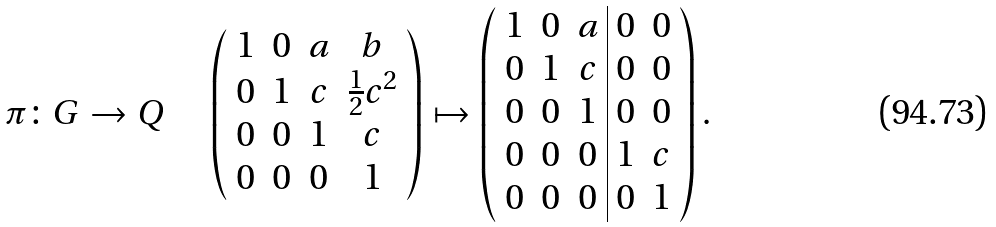Convert formula to latex. <formula><loc_0><loc_0><loc_500><loc_500>\pi \colon G \rightarrow Q \quad \left ( \begin{array} { c c c c } 1 & 0 & a & b \\ 0 & 1 & c & \frac { 1 } { 2 } c ^ { 2 } \\ 0 & 0 & 1 & c \\ 0 & 0 & 0 & 1 \end{array} \right ) \mapsto \left ( \begin{array} { c c c | c c } 1 & 0 & a & 0 & 0 \\ 0 & 1 & c & 0 & 0 \\ 0 & 0 & 1 & 0 & 0 \\ 0 & 0 & 0 & 1 & c \\ 0 & 0 & 0 & 0 & 1 \end{array} \right ) .</formula> 